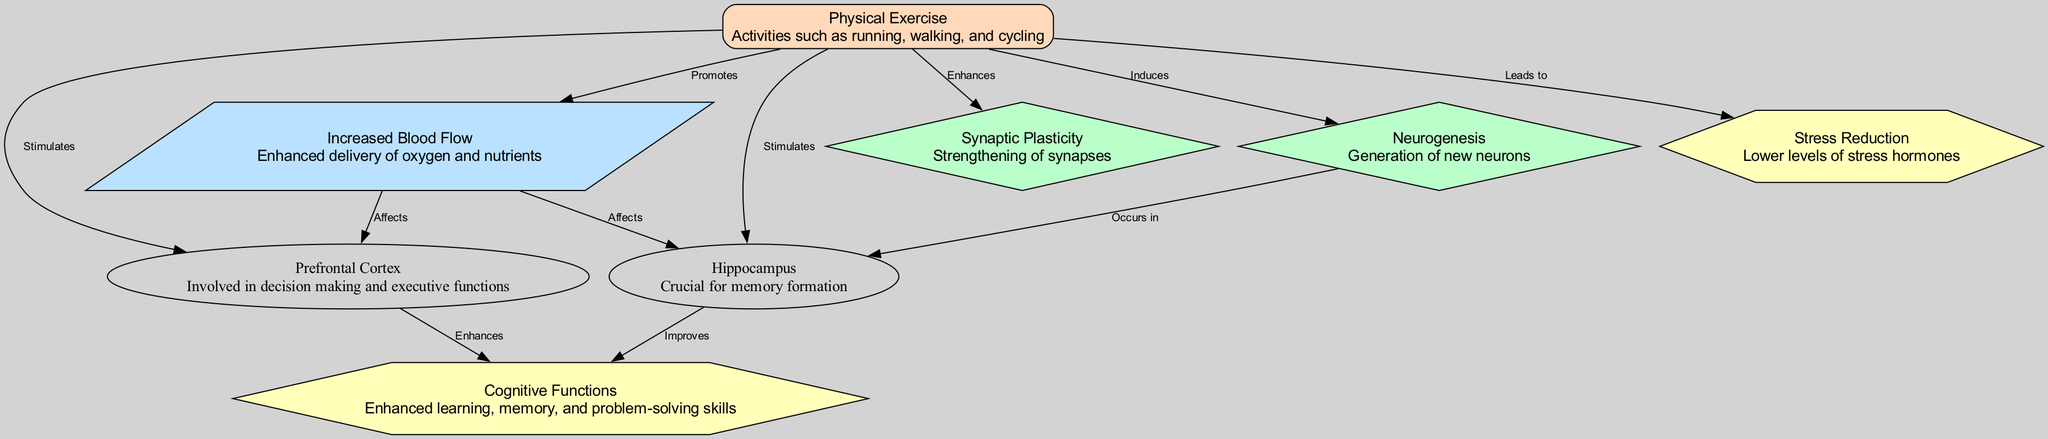What brain region is involved in decision making? The diagram indicates the Prefrontal Cortex is labeled as involved in decision making and executive functions. This information comes from the node description of the Prefrontal Cortex.
Answer: Prefrontal Cortex How many brain regions are stimulated by physical exercise? The diagram shows two brain regions connected to Physical Exercise by the "Stimulates" label: the Prefrontal Cortex and the Hippocampus. Counting these nodes gives us a total of two brain regions.
Answer: 2 What type of activity leads to stress reduction? The connection labeled "Leads to" shows that Physical Exercise is responsible for stress reduction. The benefits associated with Physical Exercise include lower levels of stress hormones.
Answer: Physical Exercise Which activity induces neurogenesis? According to the diagram, the activity that induces neurogenesis is Physical Exercise, as indicated by the line connecting Physical Exercise to the Neurogenesis node with the label "Induces."
Answer: Physical Exercise What cognitive benefit is improved by the Hippocampus? The Hippocampus enhances cognitive functions, which is indicated by the connection labeled "Improves" from the Hippocampus to the Cognitive Functions node. This means the diagram identifies this relationship.
Answer: Cognitive Functions What promotes increased blood flow to the brain? The diagram specifies that Physical Exercise promotes increased blood flow, as shown by the edge labeled "Promotes" connecting Physical Exercise to the Increased Blood Flow node.
Answer: Physical Exercise Which activity enhances synaptic plasticity? The edge labeled "Enhances" between Physical Exercise and Synaptic Plasticity shows that Physical Exercise enhances synaptic plasticity, indicating its role in strengthening neural connections.
Answer: Physical Exercise Which two brain regions are affected by increased blood flow? The diagram reveals two brain regions affected by Increased Blood Flow: the Prefrontal Cortex and the Hippocampus, as depicted by the edges labeled "Affects" connecting both brain regions to Increased Blood Flow.
Answer: Prefrontal Cortex and Hippocampus What process occurs in the Hippocampus? The edge labeled "Occurs in" from the Neurogenesis node points to the Hippocampus, indicating that neurogenesis takes place in this brain region.
Answer: Neurogenesis 